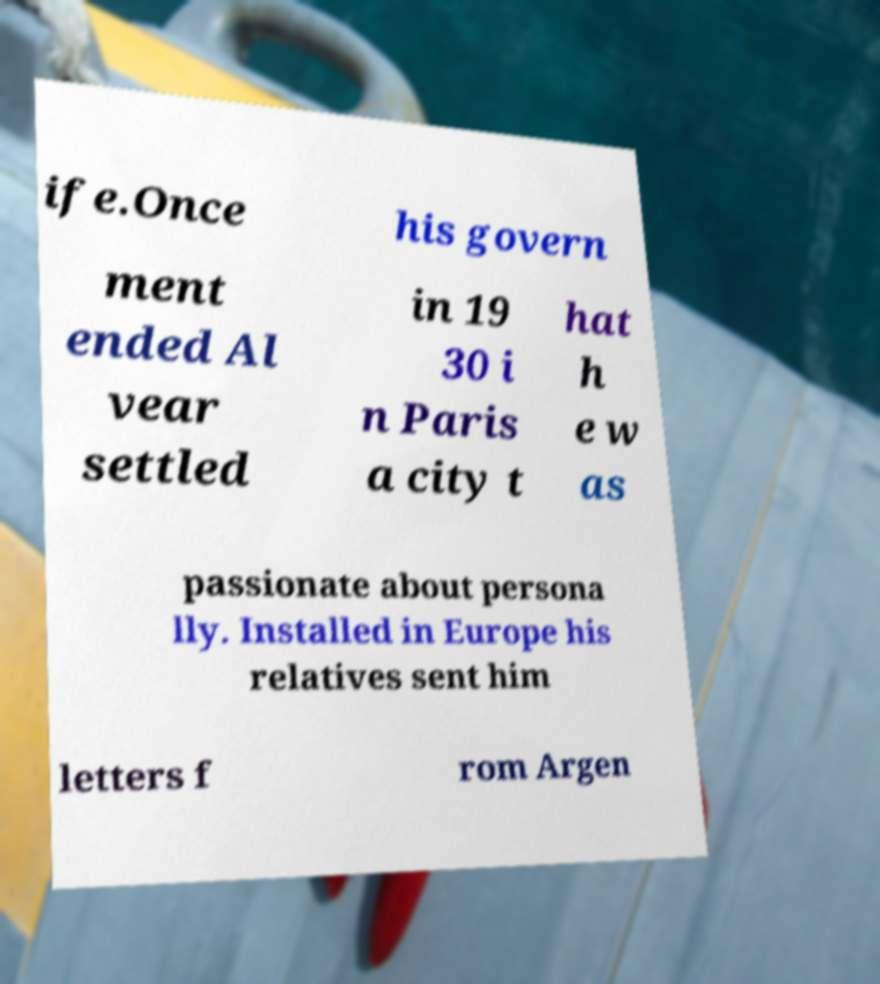Please read and relay the text visible in this image. What does it say? ife.Once his govern ment ended Al vear settled in 19 30 i n Paris a city t hat h e w as passionate about persona lly. Installed in Europe his relatives sent him letters f rom Argen 